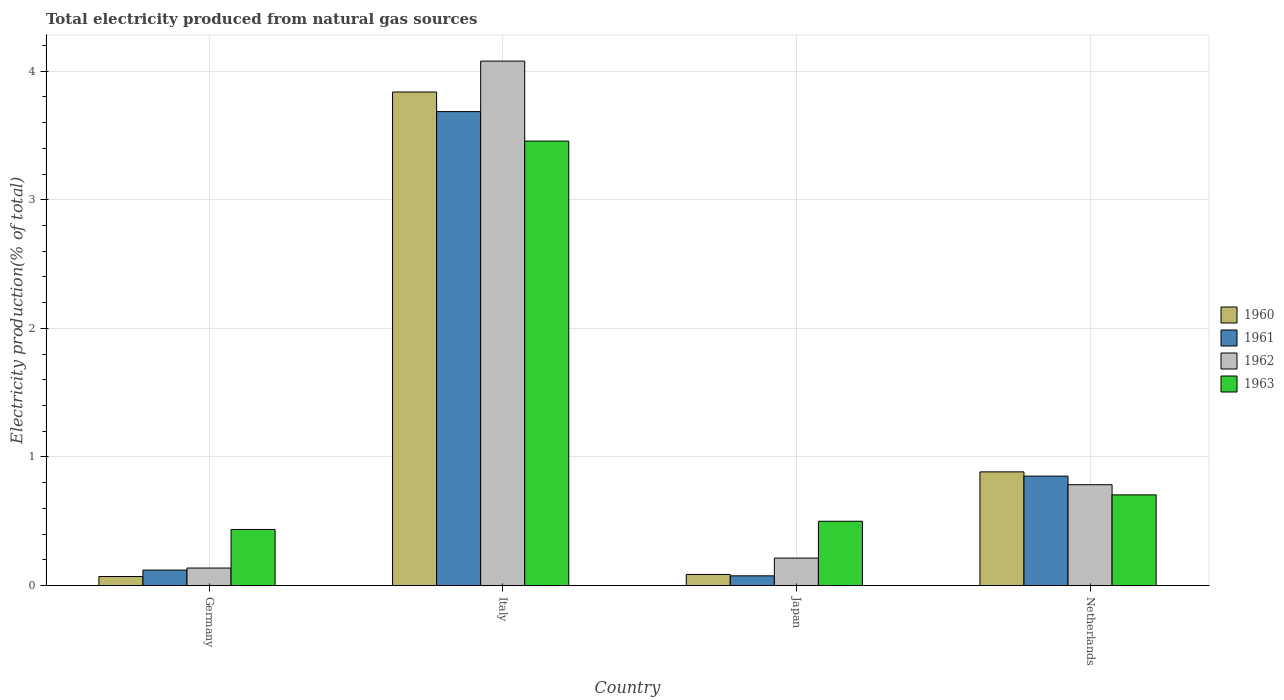How many different coloured bars are there?
Provide a short and direct response. 4. How many groups of bars are there?
Provide a succinct answer. 4. Are the number of bars per tick equal to the number of legend labels?
Provide a succinct answer. Yes. Are the number of bars on each tick of the X-axis equal?
Your response must be concise. Yes. How many bars are there on the 3rd tick from the left?
Provide a succinct answer. 4. How many bars are there on the 1st tick from the right?
Keep it short and to the point. 4. What is the label of the 3rd group of bars from the left?
Offer a terse response. Japan. What is the total electricity produced in 1961 in Italy?
Make the answer very short. 3.69. Across all countries, what is the maximum total electricity produced in 1962?
Give a very brief answer. 4.08. Across all countries, what is the minimum total electricity produced in 1961?
Your answer should be very brief. 0.08. In which country was the total electricity produced in 1963 maximum?
Your response must be concise. Italy. In which country was the total electricity produced in 1961 minimum?
Offer a terse response. Japan. What is the total total electricity produced in 1960 in the graph?
Offer a very short reply. 4.88. What is the difference between the total electricity produced in 1961 in Italy and that in Japan?
Offer a very short reply. 3.61. What is the difference between the total electricity produced in 1960 in Japan and the total electricity produced in 1961 in Germany?
Provide a short and direct response. -0.03. What is the average total electricity produced in 1960 per country?
Keep it short and to the point. 1.22. What is the difference between the total electricity produced of/in 1963 and total electricity produced of/in 1961 in Netherlands?
Offer a terse response. -0.15. In how many countries, is the total electricity produced in 1962 greater than 2.2 %?
Keep it short and to the point. 1. What is the ratio of the total electricity produced in 1961 in Germany to that in Japan?
Provide a succinct answer. 1.59. Is the total electricity produced in 1960 in Germany less than that in Netherlands?
Make the answer very short. Yes. Is the difference between the total electricity produced in 1963 in Japan and Netherlands greater than the difference between the total electricity produced in 1961 in Japan and Netherlands?
Offer a very short reply. Yes. What is the difference between the highest and the second highest total electricity produced in 1962?
Ensure brevity in your answer.  -3.29. What is the difference between the highest and the lowest total electricity produced in 1961?
Offer a terse response. 3.61. Is it the case that in every country, the sum of the total electricity produced in 1961 and total electricity produced in 1960 is greater than the sum of total electricity produced in 1962 and total electricity produced in 1963?
Ensure brevity in your answer.  No. What does the 3rd bar from the left in Netherlands represents?
Make the answer very short. 1962. What does the 3rd bar from the right in Japan represents?
Keep it short and to the point. 1961. How many bars are there?
Your answer should be very brief. 16. Are all the bars in the graph horizontal?
Your response must be concise. No. Are the values on the major ticks of Y-axis written in scientific E-notation?
Keep it short and to the point. No. Does the graph contain any zero values?
Provide a short and direct response. No. What is the title of the graph?
Provide a short and direct response. Total electricity produced from natural gas sources. What is the label or title of the X-axis?
Offer a very short reply. Country. What is the Electricity production(% of total) in 1960 in Germany?
Offer a terse response. 0.07. What is the Electricity production(% of total) in 1961 in Germany?
Offer a very short reply. 0.12. What is the Electricity production(% of total) in 1962 in Germany?
Make the answer very short. 0.14. What is the Electricity production(% of total) of 1963 in Germany?
Keep it short and to the point. 0.44. What is the Electricity production(% of total) in 1960 in Italy?
Keep it short and to the point. 3.84. What is the Electricity production(% of total) of 1961 in Italy?
Keep it short and to the point. 3.69. What is the Electricity production(% of total) of 1962 in Italy?
Provide a short and direct response. 4.08. What is the Electricity production(% of total) of 1963 in Italy?
Give a very brief answer. 3.46. What is the Electricity production(% of total) of 1960 in Japan?
Your answer should be very brief. 0.09. What is the Electricity production(% of total) of 1961 in Japan?
Your answer should be compact. 0.08. What is the Electricity production(% of total) in 1962 in Japan?
Keep it short and to the point. 0.21. What is the Electricity production(% of total) in 1963 in Japan?
Ensure brevity in your answer.  0.5. What is the Electricity production(% of total) of 1960 in Netherlands?
Provide a succinct answer. 0.88. What is the Electricity production(% of total) of 1961 in Netherlands?
Provide a short and direct response. 0.85. What is the Electricity production(% of total) in 1962 in Netherlands?
Provide a short and direct response. 0.78. What is the Electricity production(% of total) of 1963 in Netherlands?
Offer a terse response. 0.71. Across all countries, what is the maximum Electricity production(% of total) of 1960?
Offer a terse response. 3.84. Across all countries, what is the maximum Electricity production(% of total) of 1961?
Provide a short and direct response. 3.69. Across all countries, what is the maximum Electricity production(% of total) of 1962?
Your answer should be very brief. 4.08. Across all countries, what is the maximum Electricity production(% of total) of 1963?
Make the answer very short. 3.46. Across all countries, what is the minimum Electricity production(% of total) of 1960?
Offer a terse response. 0.07. Across all countries, what is the minimum Electricity production(% of total) of 1961?
Your answer should be very brief. 0.08. Across all countries, what is the minimum Electricity production(% of total) of 1962?
Your answer should be very brief. 0.14. Across all countries, what is the minimum Electricity production(% of total) of 1963?
Your answer should be very brief. 0.44. What is the total Electricity production(% of total) of 1960 in the graph?
Provide a succinct answer. 4.88. What is the total Electricity production(% of total) in 1961 in the graph?
Offer a very short reply. 4.73. What is the total Electricity production(% of total) of 1962 in the graph?
Provide a short and direct response. 5.21. What is the total Electricity production(% of total) of 1963 in the graph?
Your response must be concise. 5.1. What is the difference between the Electricity production(% of total) in 1960 in Germany and that in Italy?
Your answer should be compact. -3.77. What is the difference between the Electricity production(% of total) of 1961 in Germany and that in Italy?
Make the answer very short. -3.57. What is the difference between the Electricity production(% of total) in 1962 in Germany and that in Italy?
Provide a short and direct response. -3.94. What is the difference between the Electricity production(% of total) in 1963 in Germany and that in Italy?
Your response must be concise. -3.02. What is the difference between the Electricity production(% of total) of 1960 in Germany and that in Japan?
Your answer should be compact. -0.02. What is the difference between the Electricity production(% of total) of 1961 in Germany and that in Japan?
Your answer should be very brief. 0.04. What is the difference between the Electricity production(% of total) in 1962 in Germany and that in Japan?
Make the answer very short. -0.08. What is the difference between the Electricity production(% of total) of 1963 in Germany and that in Japan?
Ensure brevity in your answer.  -0.06. What is the difference between the Electricity production(% of total) in 1960 in Germany and that in Netherlands?
Make the answer very short. -0.81. What is the difference between the Electricity production(% of total) of 1961 in Germany and that in Netherlands?
Make the answer very short. -0.73. What is the difference between the Electricity production(% of total) of 1962 in Germany and that in Netherlands?
Offer a very short reply. -0.65. What is the difference between the Electricity production(% of total) in 1963 in Germany and that in Netherlands?
Ensure brevity in your answer.  -0.27. What is the difference between the Electricity production(% of total) in 1960 in Italy and that in Japan?
Keep it short and to the point. 3.75. What is the difference between the Electricity production(% of total) of 1961 in Italy and that in Japan?
Make the answer very short. 3.61. What is the difference between the Electricity production(% of total) in 1962 in Italy and that in Japan?
Provide a short and direct response. 3.86. What is the difference between the Electricity production(% of total) in 1963 in Italy and that in Japan?
Offer a terse response. 2.96. What is the difference between the Electricity production(% of total) of 1960 in Italy and that in Netherlands?
Give a very brief answer. 2.95. What is the difference between the Electricity production(% of total) of 1961 in Italy and that in Netherlands?
Offer a terse response. 2.83. What is the difference between the Electricity production(% of total) of 1962 in Italy and that in Netherlands?
Provide a succinct answer. 3.29. What is the difference between the Electricity production(% of total) in 1963 in Italy and that in Netherlands?
Your answer should be compact. 2.75. What is the difference between the Electricity production(% of total) in 1960 in Japan and that in Netherlands?
Your response must be concise. -0.8. What is the difference between the Electricity production(% of total) of 1961 in Japan and that in Netherlands?
Your response must be concise. -0.78. What is the difference between the Electricity production(% of total) in 1962 in Japan and that in Netherlands?
Offer a very short reply. -0.57. What is the difference between the Electricity production(% of total) of 1963 in Japan and that in Netherlands?
Your answer should be very brief. -0.21. What is the difference between the Electricity production(% of total) of 1960 in Germany and the Electricity production(% of total) of 1961 in Italy?
Keep it short and to the point. -3.62. What is the difference between the Electricity production(% of total) in 1960 in Germany and the Electricity production(% of total) in 1962 in Italy?
Your response must be concise. -4.01. What is the difference between the Electricity production(% of total) of 1960 in Germany and the Electricity production(% of total) of 1963 in Italy?
Provide a short and direct response. -3.39. What is the difference between the Electricity production(% of total) in 1961 in Germany and the Electricity production(% of total) in 1962 in Italy?
Offer a very short reply. -3.96. What is the difference between the Electricity production(% of total) of 1961 in Germany and the Electricity production(% of total) of 1963 in Italy?
Give a very brief answer. -3.34. What is the difference between the Electricity production(% of total) in 1962 in Germany and the Electricity production(% of total) in 1963 in Italy?
Offer a very short reply. -3.32. What is the difference between the Electricity production(% of total) of 1960 in Germany and the Electricity production(% of total) of 1961 in Japan?
Offer a terse response. -0.01. What is the difference between the Electricity production(% of total) of 1960 in Germany and the Electricity production(% of total) of 1962 in Japan?
Your answer should be compact. -0.14. What is the difference between the Electricity production(% of total) in 1960 in Germany and the Electricity production(% of total) in 1963 in Japan?
Your answer should be very brief. -0.43. What is the difference between the Electricity production(% of total) of 1961 in Germany and the Electricity production(% of total) of 1962 in Japan?
Provide a short and direct response. -0.09. What is the difference between the Electricity production(% of total) in 1961 in Germany and the Electricity production(% of total) in 1963 in Japan?
Provide a succinct answer. -0.38. What is the difference between the Electricity production(% of total) in 1962 in Germany and the Electricity production(% of total) in 1963 in Japan?
Make the answer very short. -0.36. What is the difference between the Electricity production(% of total) of 1960 in Germany and the Electricity production(% of total) of 1961 in Netherlands?
Your response must be concise. -0.78. What is the difference between the Electricity production(% of total) in 1960 in Germany and the Electricity production(% of total) in 1962 in Netherlands?
Provide a short and direct response. -0.71. What is the difference between the Electricity production(% of total) in 1960 in Germany and the Electricity production(% of total) in 1963 in Netherlands?
Give a very brief answer. -0.64. What is the difference between the Electricity production(% of total) of 1961 in Germany and the Electricity production(% of total) of 1962 in Netherlands?
Provide a short and direct response. -0.66. What is the difference between the Electricity production(% of total) of 1961 in Germany and the Electricity production(% of total) of 1963 in Netherlands?
Provide a succinct answer. -0.58. What is the difference between the Electricity production(% of total) in 1962 in Germany and the Electricity production(% of total) in 1963 in Netherlands?
Keep it short and to the point. -0.57. What is the difference between the Electricity production(% of total) in 1960 in Italy and the Electricity production(% of total) in 1961 in Japan?
Ensure brevity in your answer.  3.76. What is the difference between the Electricity production(% of total) of 1960 in Italy and the Electricity production(% of total) of 1962 in Japan?
Provide a short and direct response. 3.62. What is the difference between the Electricity production(% of total) in 1960 in Italy and the Electricity production(% of total) in 1963 in Japan?
Your answer should be very brief. 3.34. What is the difference between the Electricity production(% of total) of 1961 in Italy and the Electricity production(% of total) of 1962 in Japan?
Your answer should be compact. 3.47. What is the difference between the Electricity production(% of total) in 1961 in Italy and the Electricity production(% of total) in 1963 in Japan?
Keep it short and to the point. 3.19. What is the difference between the Electricity production(% of total) of 1962 in Italy and the Electricity production(% of total) of 1963 in Japan?
Provide a succinct answer. 3.58. What is the difference between the Electricity production(% of total) in 1960 in Italy and the Electricity production(% of total) in 1961 in Netherlands?
Offer a terse response. 2.99. What is the difference between the Electricity production(% of total) in 1960 in Italy and the Electricity production(% of total) in 1962 in Netherlands?
Give a very brief answer. 3.05. What is the difference between the Electricity production(% of total) of 1960 in Italy and the Electricity production(% of total) of 1963 in Netherlands?
Your response must be concise. 3.13. What is the difference between the Electricity production(% of total) in 1961 in Italy and the Electricity production(% of total) in 1962 in Netherlands?
Your answer should be very brief. 2.9. What is the difference between the Electricity production(% of total) in 1961 in Italy and the Electricity production(% of total) in 1963 in Netherlands?
Offer a terse response. 2.98. What is the difference between the Electricity production(% of total) in 1962 in Italy and the Electricity production(% of total) in 1963 in Netherlands?
Provide a succinct answer. 3.37. What is the difference between the Electricity production(% of total) of 1960 in Japan and the Electricity production(% of total) of 1961 in Netherlands?
Provide a short and direct response. -0.76. What is the difference between the Electricity production(% of total) in 1960 in Japan and the Electricity production(% of total) in 1962 in Netherlands?
Offer a very short reply. -0.7. What is the difference between the Electricity production(% of total) of 1960 in Japan and the Electricity production(% of total) of 1963 in Netherlands?
Give a very brief answer. -0.62. What is the difference between the Electricity production(% of total) in 1961 in Japan and the Electricity production(% of total) in 1962 in Netherlands?
Offer a terse response. -0.71. What is the difference between the Electricity production(% of total) in 1961 in Japan and the Electricity production(% of total) in 1963 in Netherlands?
Keep it short and to the point. -0.63. What is the difference between the Electricity production(% of total) of 1962 in Japan and the Electricity production(% of total) of 1963 in Netherlands?
Ensure brevity in your answer.  -0.49. What is the average Electricity production(% of total) in 1960 per country?
Make the answer very short. 1.22. What is the average Electricity production(% of total) in 1961 per country?
Offer a terse response. 1.18. What is the average Electricity production(% of total) of 1962 per country?
Provide a short and direct response. 1.3. What is the average Electricity production(% of total) in 1963 per country?
Provide a succinct answer. 1.27. What is the difference between the Electricity production(% of total) in 1960 and Electricity production(% of total) in 1962 in Germany?
Offer a terse response. -0.07. What is the difference between the Electricity production(% of total) in 1960 and Electricity production(% of total) in 1963 in Germany?
Keep it short and to the point. -0.37. What is the difference between the Electricity production(% of total) in 1961 and Electricity production(% of total) in 1962 in Germany?
Ensure brevity in your answer.  -0.02. What is the difference between the Electricity production(% of total) of 1961 and Electricity production(% of total) of 1963 in Germany?
Offer a terse response. -0.32. What is the difference between the Electricity production(% of total) of 1962 and Electricity production(% of total) of 1963 in Germany?
Your answer should be compact. -0.3. What is the difference between the Electricity production(% of total) in 1960 and Electricity production(% of total) in 1961 in Italy?
Keep it short and to the point. 0.15. What is the difference between the Electricity production(% of total) of 1960 and Electricity production(% of total) of 1962 in Italy?
Keep it short and to the point. -0.24. What is the difference between the Electricity production(% of total) of 1960 and Electricity production(% of total) of 1963 in Italy?
Your answer should be very brief. 0.38. What is the difference between the Electricity production(% of total) in 1961 and Electricity production(% of total) in 1962 in Italy?
Ensure brevity in your answer.  -0.39. What is the difference between the Electricity production(% of total) in 1961 and Electricity production(% of total) in 1963 in Italy?
Give a very brief answer. 0.23. What is the difference between the Electricity production(% of total) in 1962 and Electricity production(% of total) in 1963 in Italy?
Give a very brief answer. 0.62. What is the difference between the Electricity production(% of total) in 1960 and Electricity production(% of total) in 1961 in Japan?
Offer a very short reply. 0.01. What is the difference between the Electricity production(% of total) in 1960 and Electricity production(% of total) in 1962 in Japan?
Your answer should be compact. -0.13. What is the difference between the Electricity production(% of total) of 1960 and Electricity production(% of total) of 1963 in Japan?
Give a very brief answer. -0.41. What is the difference between the Electricity production(% of total) of 1961 and Electricity production(% of total) of 1962 in Japan?
Make the answer very short. -0.14. What is the difference between the Electricity production(% of total) of 1961 and Electricity production(% of total) of 1963 in Japan?
Give a very brief answer. -0.42. What is the difference between the Electricity production(% of total) in 1962 and Electricity production(% of total) in 1963 in Japan?
Offer a very short reply. -0.29. What is the difference between the Electricity production(% of total) of 1960 and Electricity production(% of total) of 1961 in Netherlands?
Offer a terse response. 0.03. What is the difference between the Electricity production(% of total) of 1960 and Electricity production(% of total) of 1962 in Netherlands?
Offer a very short reply. 0.1. What is the difference between the Electricity production(% of total) in 1960 and Electricity production(% of total) in 1963 in Netherlands?
Your answer should be very brief. 0.18. What is the difference between the Electricity production(% of total) in 1961 and Electricity production(% of total) in 1962 in Netherlands?
Ensure brevity in your answer.  0.07. What is the difference between the Electricity production(% of total) of 1961 and Electricity production(% of total) of 1963 in Netherlands?
Keep it short and to the point. 0.15. What is the difference between the Electricity production(% of total) in 1962 and Electricity production(% of total) in 1963 in Netherlands?
Offer a very short reply. 0.08. What is the ratio of the Electricity production(% of total) in 1960 in Germany to that in Italy?
Ensure brevity in your answer.  0.02. What is the ratio of the Electricity production(% of total) of 1961 in Germany to that in Italy?
Offer a very short reply. 0.03. What is the ratio of the Electricity production(% of total) of 1962 in Germany to that in Italy?
Your response must be concise. 0.03. What is the ratio of the Electricity production(% of total) of 1963 in Germany to that in Italy?
Keep it short and to the point. 0.13. What is the ratio of the Electricity production(% of total) of 1960 in Germany to that in Japan?
Your answer should be compact. 0.81. What is the ratio of the Electricity production(% of total) of 1961 in Germany to that in Japan?
Provide a short and direct response. 1.59. What is the ratio of the Electricity production(% of total) in 1962 in Germany to that in Japan?
Your response must be concise. 0.64. What is the ratio of the Electricity production(% of total) in 1963 in Germany to that in Japan?
Ensure brevity in your answer.  0.87. What is the ratio of the Electricity production(% of total) in 1960 in Germany to that in Netherlands?
Offer a very short reply. 0.08. What is the ratio of the Electricity production(% of total) in 1961 in Germany to that in Netherlands?
Your answer should be very brief. 0.14. What is the ratio of the Electricity production(% of total) in 1962 in Germany to that in Netherlands?
Make the answer very short. 0.17. What is the ratio of the Electricity production(% of total) in 1963 in Germany to that in Netherlands?
Your response must be concise. 0.62. What is the ratio of the Electricity production(% of total) in 1960 in Italy to that in Japan?
Your response must be concise. 44.33. What is the ratio of the Electricity production(% of total) of 1961 in Italy to that in Japan?
Ensure brevity in your answer.  48.69. What is the ratio of the Electricity production(% of total) in 1962 in Italy to that in Japan?
Your response must be concise. 19.09. What is the ratio of the Electricity production(% of total) of 1963 in Italy to that in Japan?
Your answer should be very brief. 6.91. What is the ratio of the Electricity production(% of total) of 1960 in Italy to that in Netherlands?
Offer a very short reply. 4.34. What is the ratio of the Electricity production(% of total) of 1961 in Italy to that in Netherlands?
Your answer should be compact. 4.33. What is the ratio of the Electricity production(% of total) of 1962 in Italy to that in Netherlands?
Your answer should be very brief. 5.2. What is the ratio of the Electricity production(% of total) of 1963 in Italy to that in Netherlands?
Provide a short and direct response. 4.9. What is the ratio of the Electricity production(% of total) in 1960 in Japan to that in Netherlands?
Provide a succinct answer. 0.1. What is the ratio of the Electricity production(% of total) in 1961 in Japan to that in Netherlands?
Your answer should be compact. 0.09. What is the ratio of the Electricity production(% of total) of 1962 in Japan to that in Netherlands?
Make the answer very short. 0.27. What is the ratio of the Electricity production(% of total) of 1963 in Japan to that in Netherlands?
Give a very brief answer. 0.71. What is the difference between the highest and the second highest Electricity production(% of total) of 1960?
Keep it short and to the point. 2.95. What is the difference between the highest and the second highest Electricity production(% of total) in 1961?
Make the answer very short. 2.83. What is the difference between the highest and the second highest Electricity production(% of total) in 1962?
Provide a succinct answer. 3.29. What is the difference between the highest and the second highest Electricity production(% of total) of 1963?
Offer a terse response. 2.75. What is the difference between the highest and the lowest Electricity production(% of total) in 1960?
Your answer should be very brief. 3.77. What is the difference between the highest and the lowest Electricity production(% of total) in 1961?
Your answer should be very brief. 3.61. What is the difference between the highest and the lowest Electricity production(% of total) in 1962?
Give a very brief answer. 3.94. What is the difference between the highest and the lowest Electricity production(% of total) in 1963?
Your answer should be compact. 3.02. 